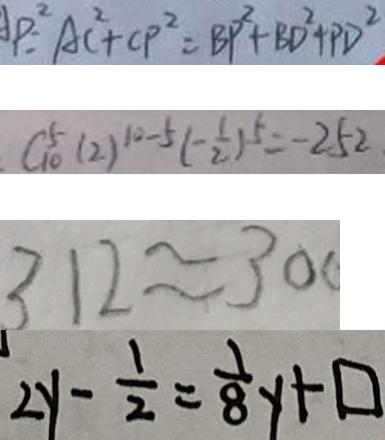Convert formula to latex. <formula><loc_0><loc_0><loc_500><loc_500>A P ^ { 2 } = A C ^ { 2 } + C P ^ { 2 } = B P ^ { 2 } + B D ^ { 2 } + P D ^ { 2 } 
 C _ { 1 0 } ^ { 5 } ( 2 ) ^ { 1 0 - 5 } ( - \frac { 1 } { 2 } ) ^ { 5 } = - 2 5 2 . 
 3 1 2 \approx 3 0 0 
 2 y - \frac { 1 } { 2 } = \frac { 1 } { 8 } y + \square</formula> 